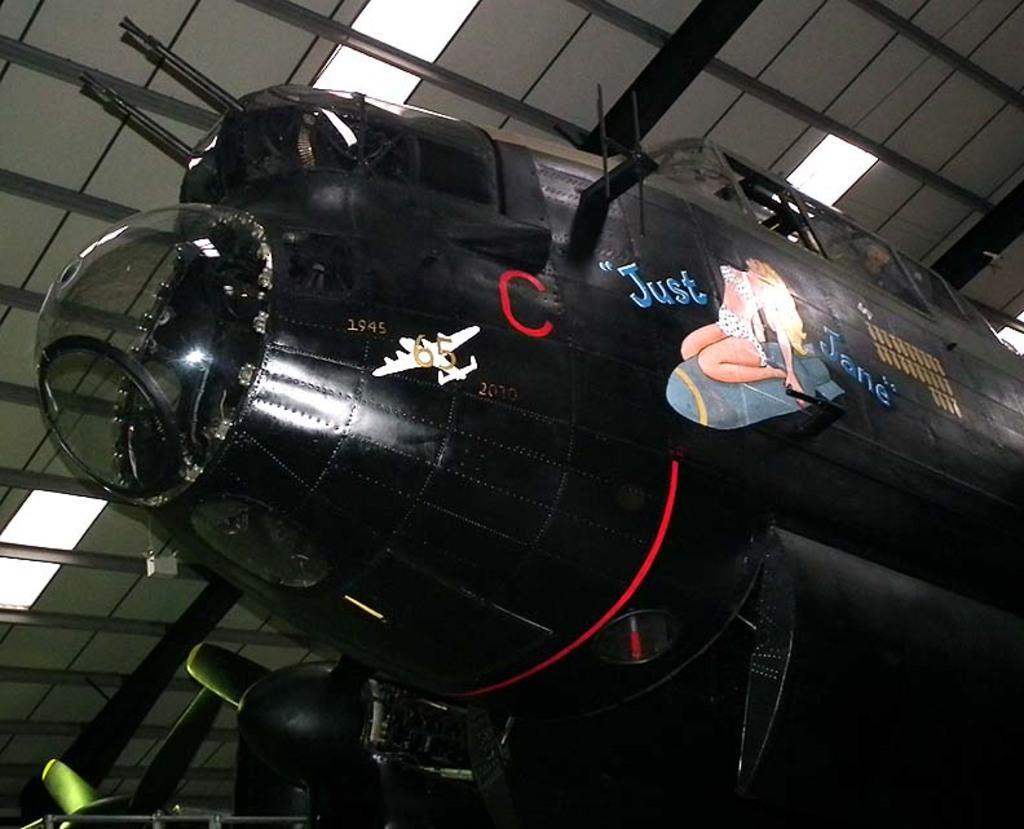Please provide a concise description of this image. In this picture we can see an aircraft and in the background we can see a roof and lights. 